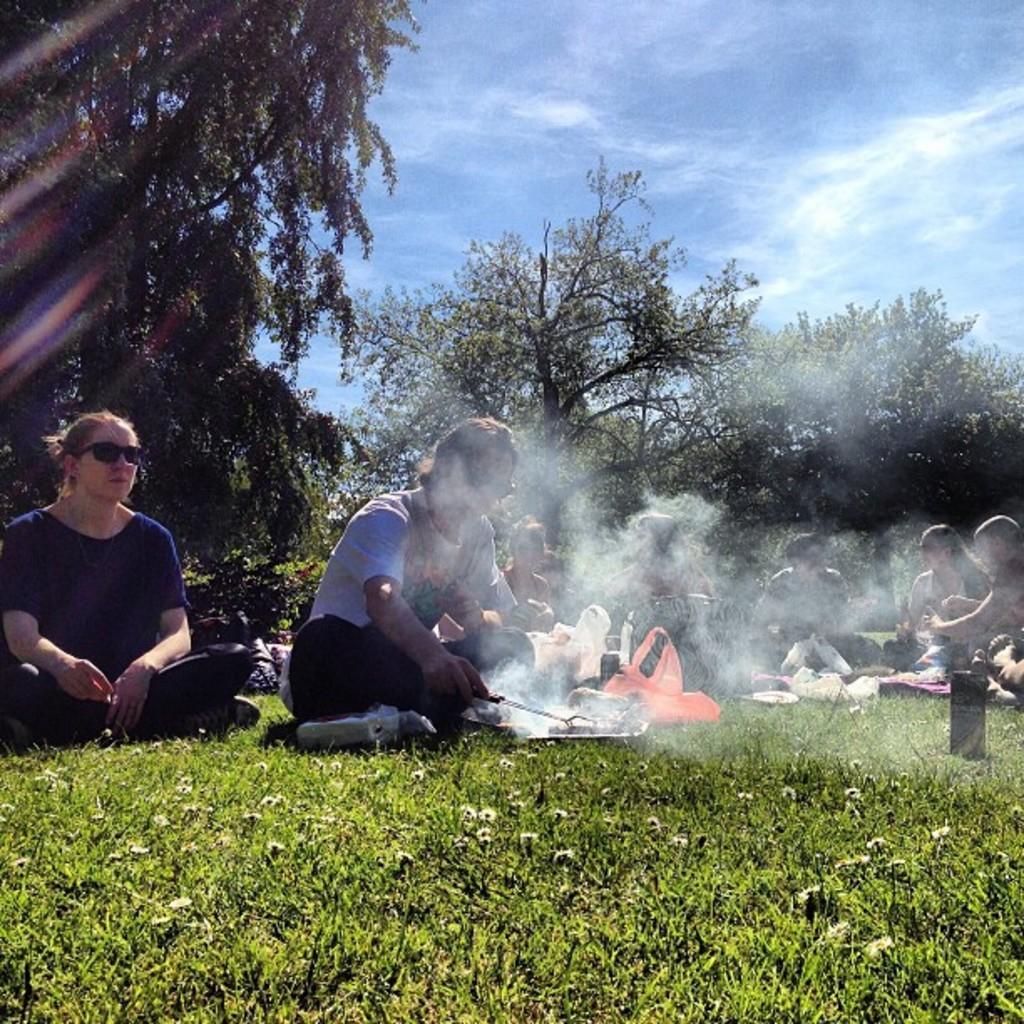In one or two sentences, can you explain what this image depicts? In this image we can see persons sitting on the grass. In the background we can see trees, sky and clouds. 